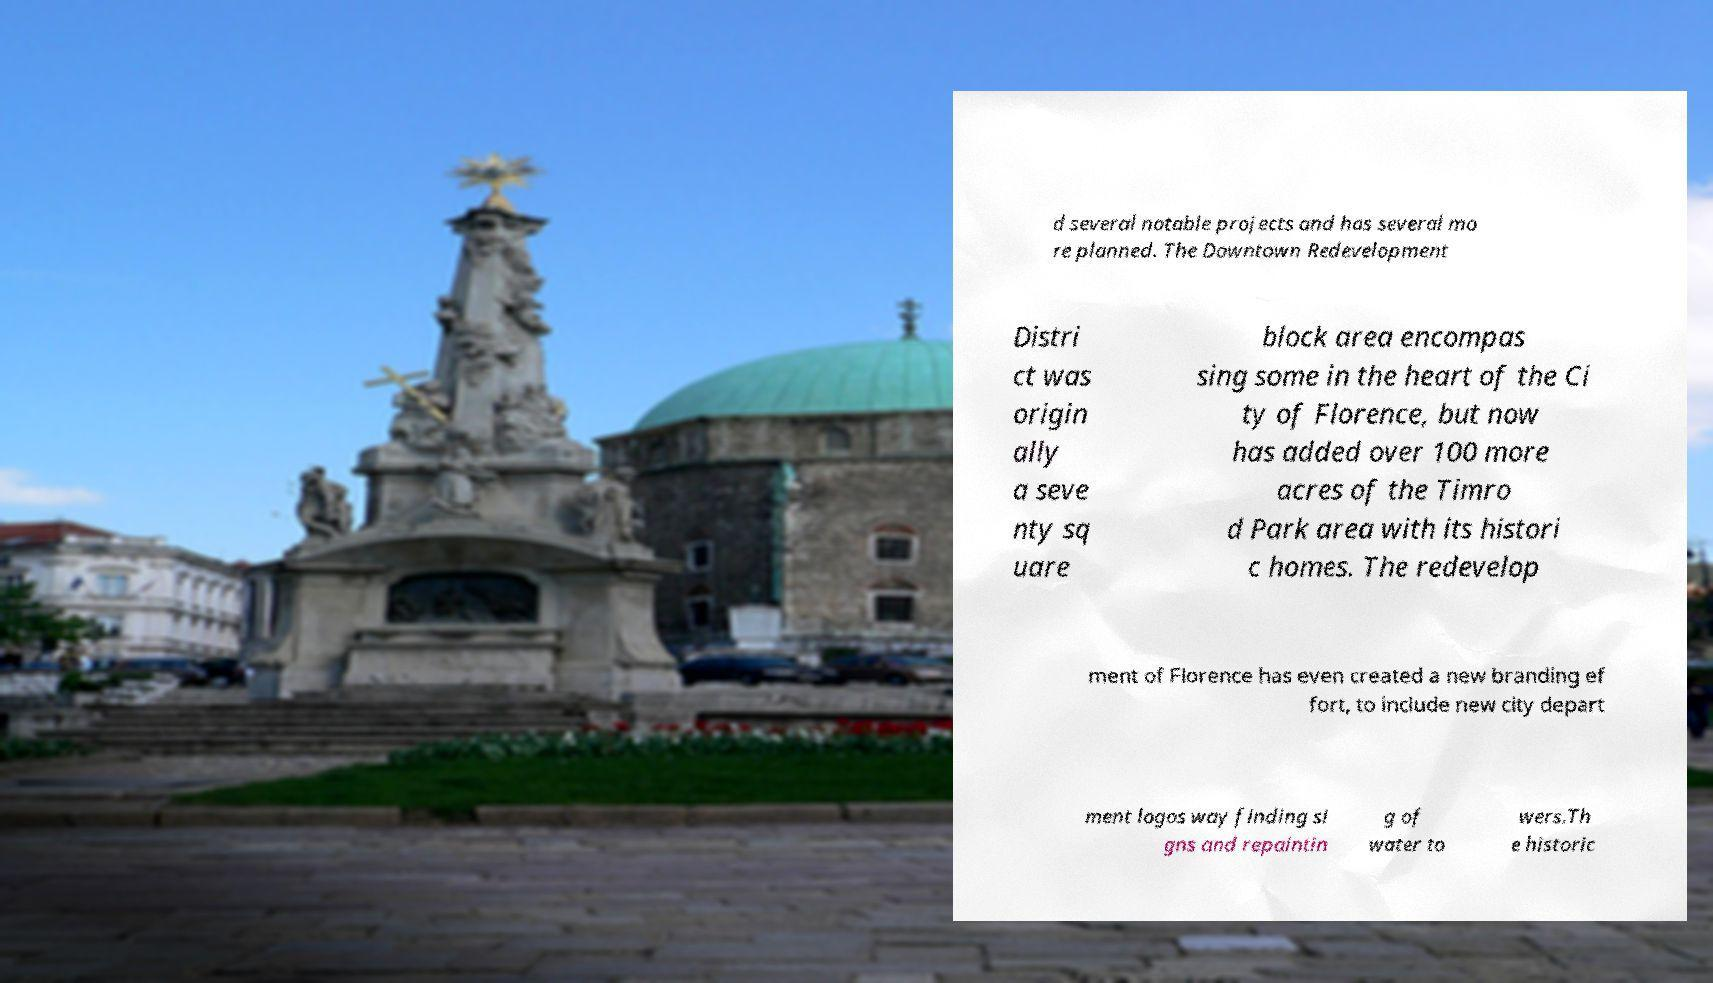Could you extract and type out the text from this image? d several notable projects and has several mo re planned. The Downtown Redevelopment Distri ct was origin ally a seve nty sq uare block area encompas sing some in the heart of the Ci ty of Florence, but now has added over 100 more acres of the Timro d Park area with its histori c homes. The redevelop ment of Florence has even created a new branding ef fort, to include new city depart ment logos way finding si gns and repaintin g of water to wers.Th e historic 